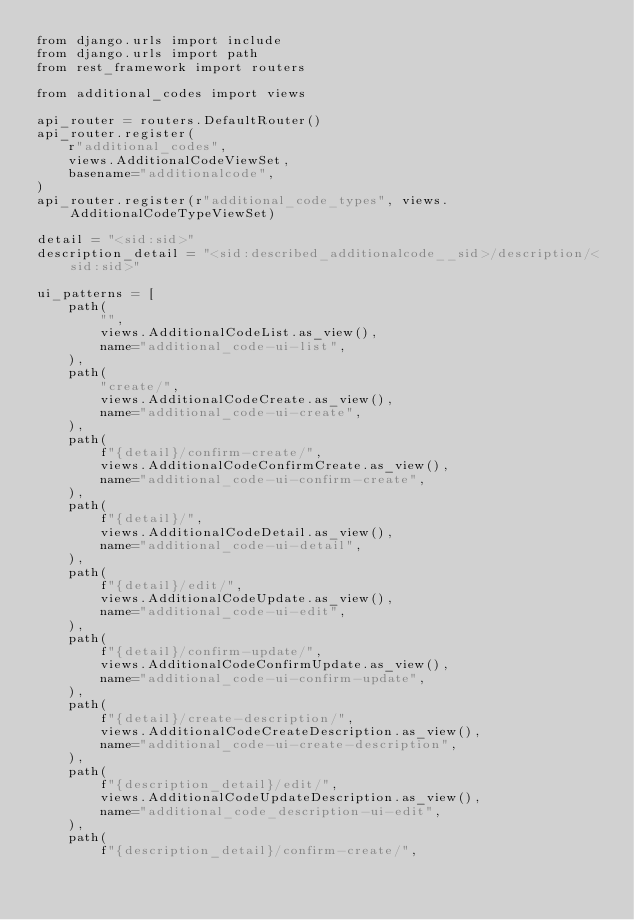<code> <loc_0><loc_0><loc_500><loc_500><_Python_>from django.urls import include
from django.urls import path
from rest_framework import routers

from additional_codes import views

api_router = routers.DefaultRouter()
api_router.register(
    r"additional_codes",
    views.AdditionalCodeViewSet,
    basename="additionalcode",
)
api_router.register(r"additional_code_types", views.AdditionalCodeTypeViewSet)

detail = "<sid:sid>"
description_detail = "<sid:described_additionalcode__sid>/description/<sid:sid>"

ui_patterns = [
    path(
        "",
        views.AdditionalCodeList.as_view(),
        name="additional_code-ui-list",
    ),
    path(
        "create/",
        views.AdditionalCodeCreate.as_view(),
        name="additional_code-ui-create",
    ),
    path(
        f"{detail}/confirm-create/",
        views.AdditionalCodeConfirmCreate.as_view(),
        name="additional_code-ui-confirm-create",
    ),
    path(
        f"{detail}/",
        views.AdditionalCodeDetail.as_view(),
        name="additional_code-ui-detail",
    ),
    path(
        f"{detail}/edit/",
        views.AdditionalCodeUpdate.as_view(),
        name="additional_code-ui-edit",
    ),
    path(
        f"{detail}/confirm-update/",
        views.AdditionalCodeConfirmUpdate.as_view(),
        name="additional_code-ui-confirm-update",
    ),
    path(
        f"{detail}/create-description/",
        views.AdditionalCodeCreateDescription.as_view(),
        name="additional_code-ui-create-description",
    ),
    path(
        f"{description_detail}/edit/",
        views.AdditionalCodeUpdateDescription.as_view(),
        name="additional_code_description-ui-edit",
    ),
    path(
        f"{description_detail}/confirm-create/",</code> 